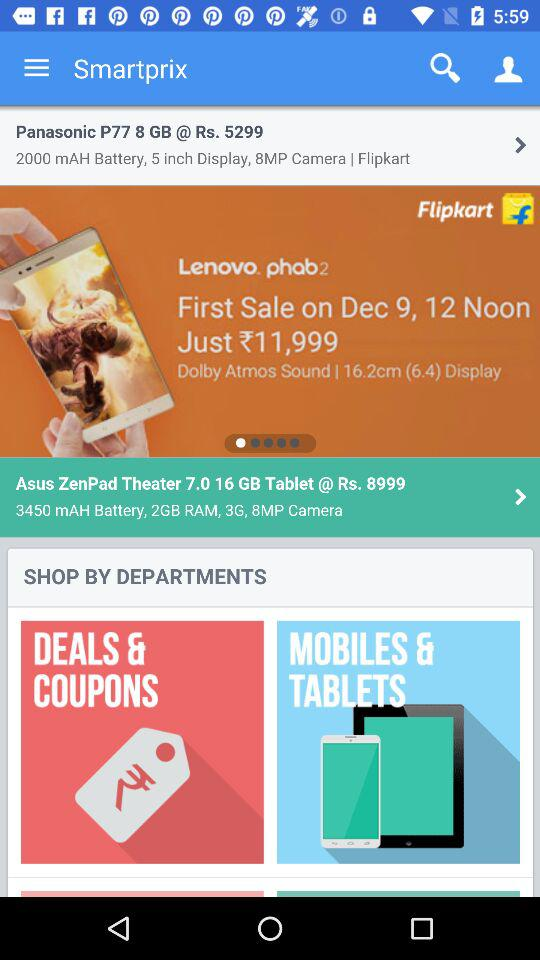What is the battery size of the Panasonic P77? The battery size of the Panasonic P77 is 2000 mAH. 